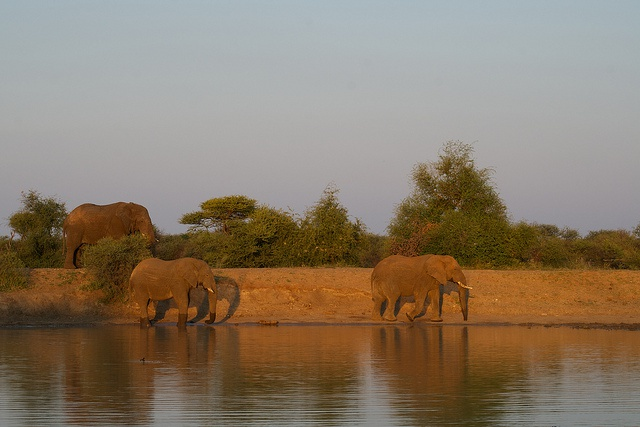Describe the objects in this image and their specific colors. I can see elephant in darkgray, maroon, brown, and black tones, elephant in darkgray, brown, maroon, and black tones, elephant in darkgray, maroon, black, and brown tones, and bird in maroon, black, gray, and darkgray tones in this image. 